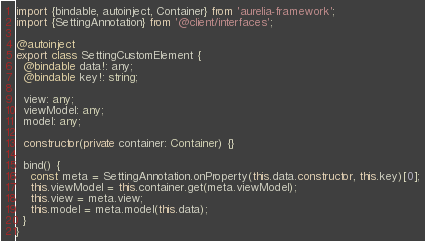Convert code to text. <code><loc_0><loc_0><loc_500><loc_500><_TypeScript_>import {bindable, autoinject, Container} from 'aurelia-framework';
import {SettingAnnotation} from '@client/interfaces';

@autoinject
export class SettingCustomElement {
  @bindable data!: any;
  @bindable key!: string;

  view: any;
  viewModel: any;
  model: any;

  constructor(private container: Container) {}

  bind() {
    const meta = SettingAnnotation.onProperty(this.data.constructor, this.key)[0];
    this.viewModel = this.container.get(meta.viewModel);
    this.view = meta.view;
    this.model = meta.model(this.data);
  }
}
</code> 